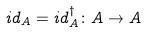Convert formula to latex. <formula><loc_0><loc_0><loc_500><loc_500>i d _ { A } = i d _ { A } ^ { \dagger } \colon A \rightarrow A</formula> 